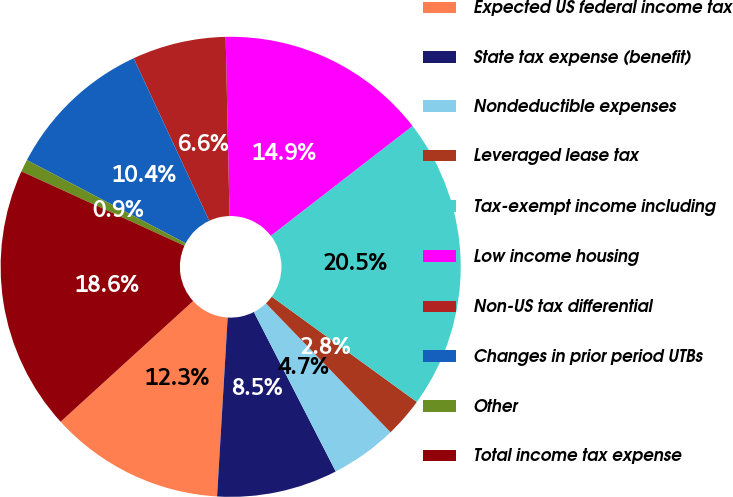Convert chart. <chart><loc_0><loc_0><loc_500><loc_500><pie_chart><fcel>Expected US federal income tax<fcel>State tax expense (benefit)<fcel>Nondeductible expenses<fcel>Leveraged lease tax<fcel>Tax-exempt income including<fcel>Low income housing<fcel>Non-US tax differential<fcel>Changes in prior period UTBs<fcel>Other<fcel>Total income tax expense<nl><fcel>12.3%<fcel>8.49%<fcel>4.68%<fcel>2.78%<fcel>20.48%<fcel>14.86%<fcel>6.58%<fcel>10.39%<fcel>0.87%<fcel>18.57%<nl></chart> 